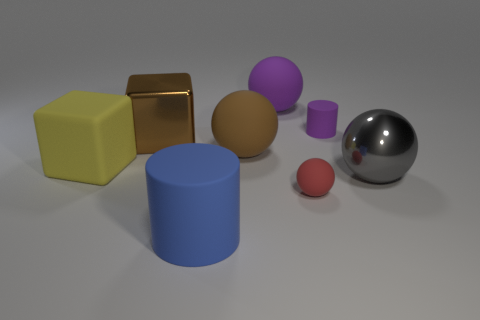Is the big brown cube made of the same material as the sphere left of the big purple object?
Your answer should be compact. No. Is the number of large yellow things greater than the number of green objects?
Your response must be concise. Yes. The brown object that is in front of the metal thing behind the big object that is to the right of the small rubber sphere is what shape?
Your answer should be very brief. Sphere. Is the material of the big sphere behind the tiny purple matte object the same as the large ball on the left side of the purple rubber sphere?
Offer a very short reply. Yes. The thing that is made of the same material as the large brown cube is what shape?
Your answer should be compact. Sphere. Are there any other things that are the same color as the tiny rubber cylinder?
Provide a short and direct response. Yes. What number of big blue rubber cylinders are there?
Provide a short and direct response. 1. There is a big yellow block left of the big thing that is in front of the large metallic sphere; what is its material?
Keep it short and to the point. Rubber. The cylinder that is behind the block that is left of the big shiny object that is behind the big yellow rubber thing is what color?
Offer a terse response. Purple. Is the color of the big metal block the same as the small ball?
Ensure brevity in your answer.  No. 